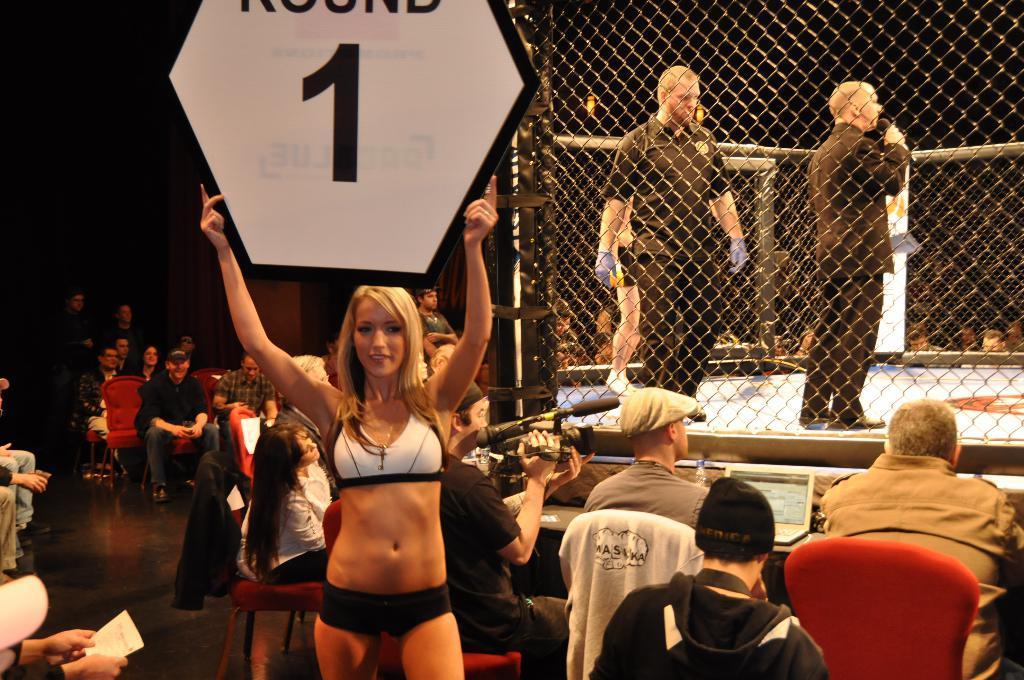Could you give a brief overview of what you see in this image? In the center of the image, we can see a lady holding a board in her hands and in the background, we can see people sitting on the chairs. On the right, we can see a mesh and through the mesh we can see two people standing and one of them is holding a mic. 